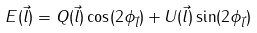Convert formula to latex. <formula><loc_0><loc_0><loc_500><loc_500>E ( \vec { l } ) = Q ( \vec { l } ) \cos ( 2 \phi _ { \vec { l } } ) + U ( \vec { l } ) \sin ( 2 \phi _ { \vec { l } } )</formula> 